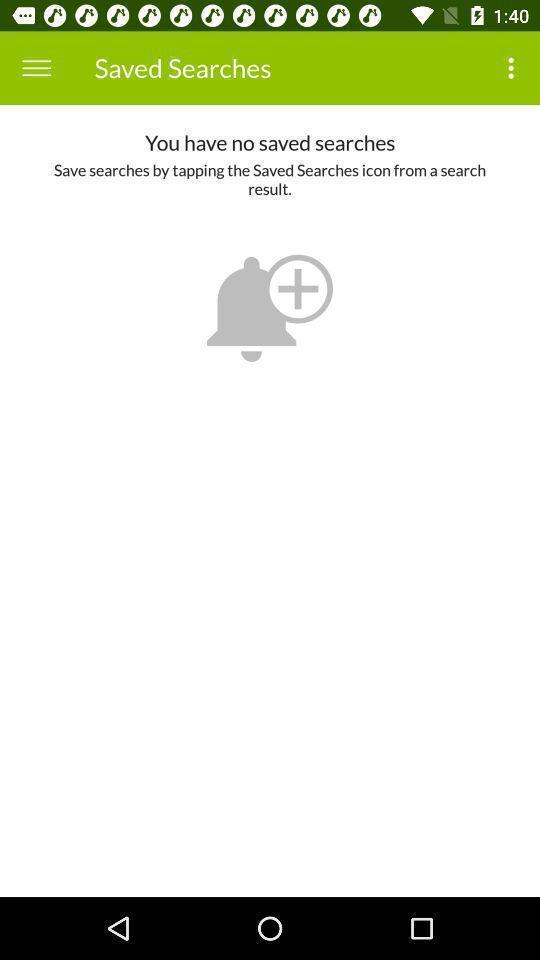Explain what's happening in this screen capture. Screen shows saved searches page in the application. 